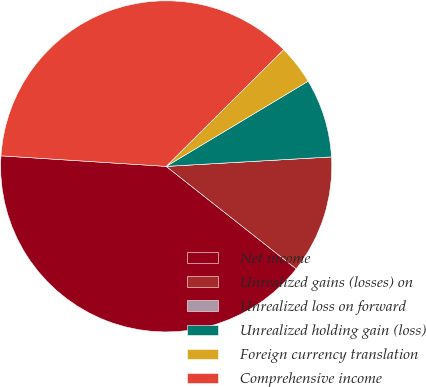Convert chart to OTSL. <chart><loc_0><loc_0><loc_500><loc_500><pie_chart><fcel>Net income<fcel>Unrealized gains (losses) on<fcel>Unrealized loss on forward<fcel>Unrealized holding gain (loss)<fcel>Foreign currency translation<fcel>Comprehensive income<nl><fcel>40.39%<fcel>11.54%<fcel>0.0%<fcel>7.69%<fcel>3.85%<fcel>36.54%<nl></chart> 